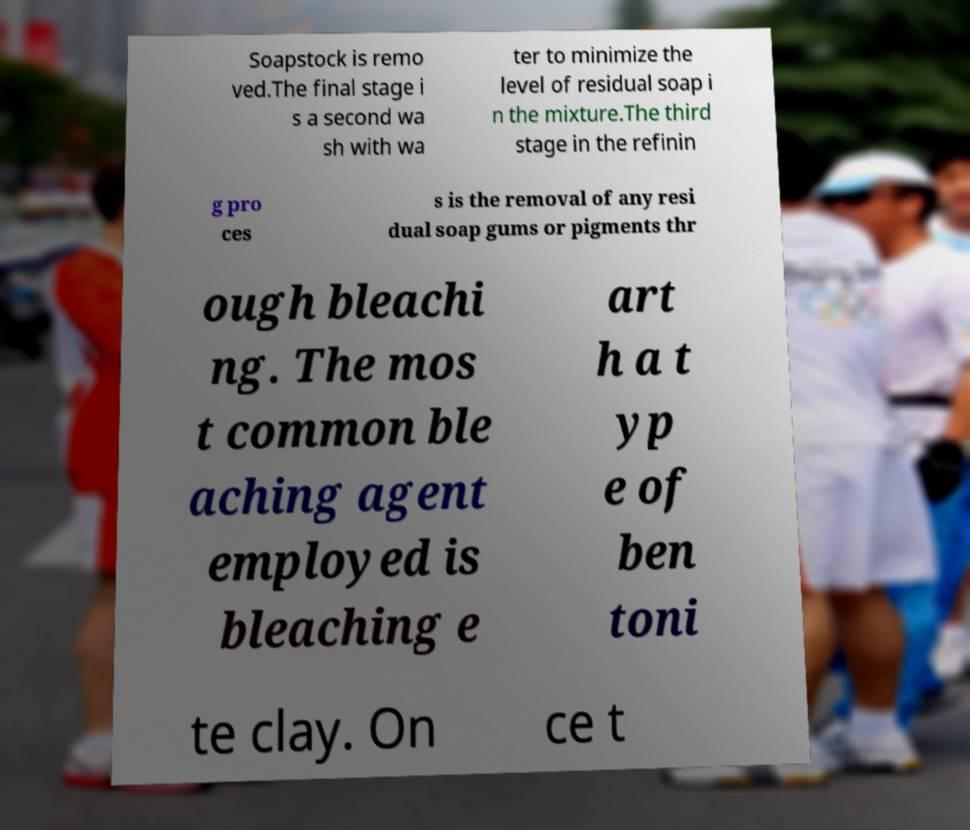Could you extract and type out the text from this image? Soapstock is remo ved.The final stage i s a second wa sh with wa ter to minimize the level of residual soap i n the mixture.The third stage in the refinin g pro ces s is the removal of any resi dual soap gums or pigments thr ough bleachi ng. The mos t common ble aching agent employed is bleaching e art h a t yp e of ben toni te clay. On ce t 